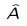<formula> <loc_0><loc_0><loc_500><loc_500>\hat { A }</formula> 